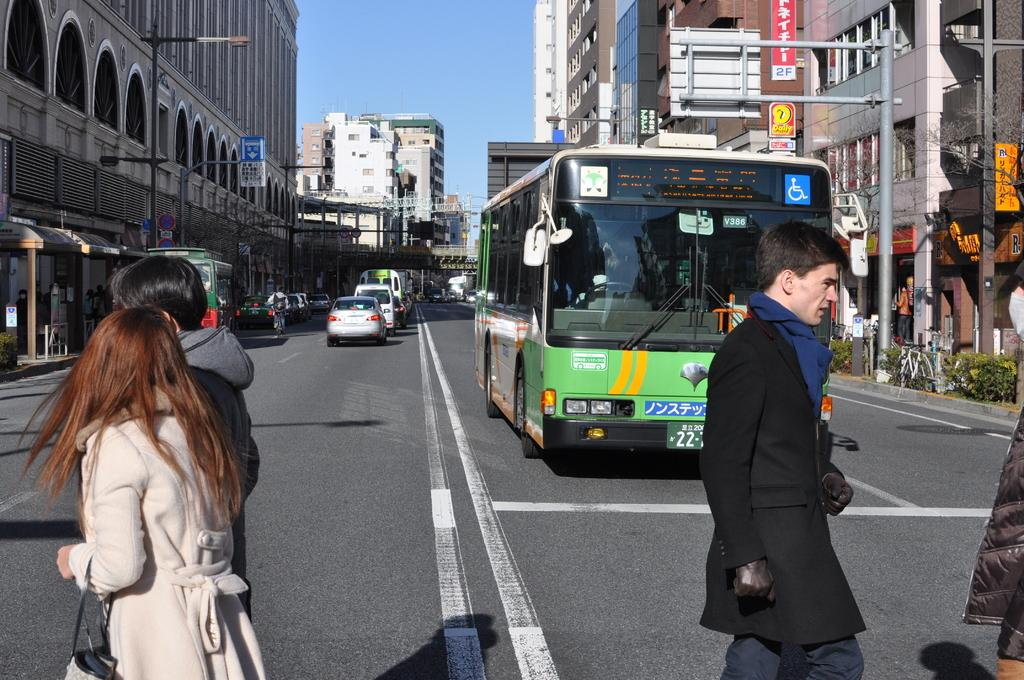<image>
Render a clear and concise summary of the photo. bus 386 is accessible for people with handicaps 